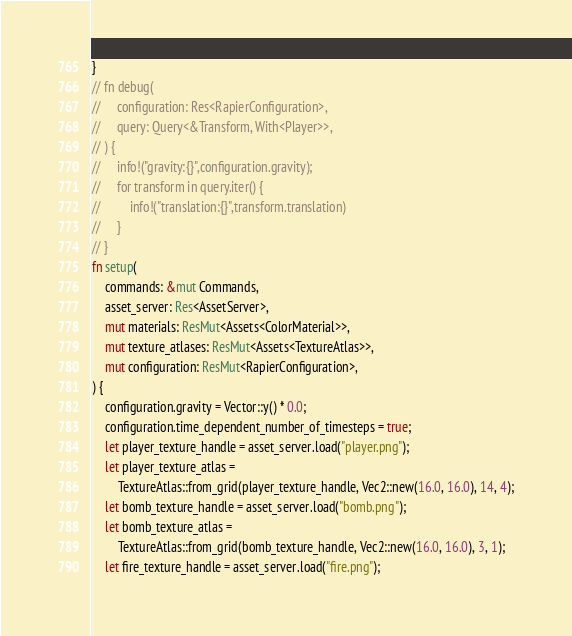<code> <loc_0><loc_0><loc_500><loc_500><_Rust_>}
// fn debug(
//     configuration: Res<RapierConfiguration>,
//     query: Query<&Transform, With<Player>>,
// ) {
//     info!("gravity:{}",configuration.gravity);
//     for transform in query.iter() {
//         info!("translation:{}",transform.translation)
//     }
// }
fn setup(
    commands: &mut Commands,
    asset_server: Res<AssetServer>,
    mut materials: ResMut<Assets<ColorMaterial>>,
    mut texture_atlases: ResMut<Assets<TextureAtlas>>,
    mut configuration: ResMut<RapierConfiguration>,
) {
    configuration.gravity = Vector::y() * 0.0;
    configuration.time_dependent_number_of_timesteps = true;
    let player_texture_handle = asset_server.load("player.png");
    let player_texture_atlas =
        TextureAtlas::from_grid(player_texture_handle, Vec2::new(16.0, 16.0), 14, 4);
    let bomb_texture_handle = asset_server.load("bomb.png");
    let bomb_texture_atlas =
        TextureAtlas::from_grid(bomb_texture_handle, Vec2::new(16.0, 16.0), 3, 1);
    let fire_texture_handle = asset_server.load("fire.png");</code> 